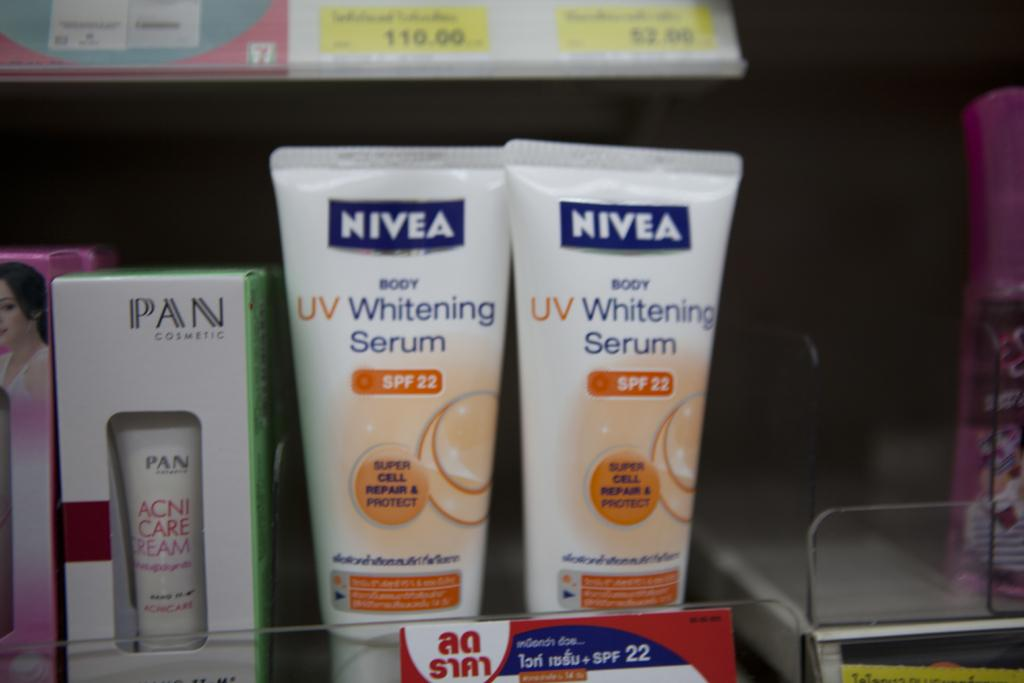<image>
Render a clear and concise summary of the photo. White squeeze bottle of Nivea UV Whitening Serum 